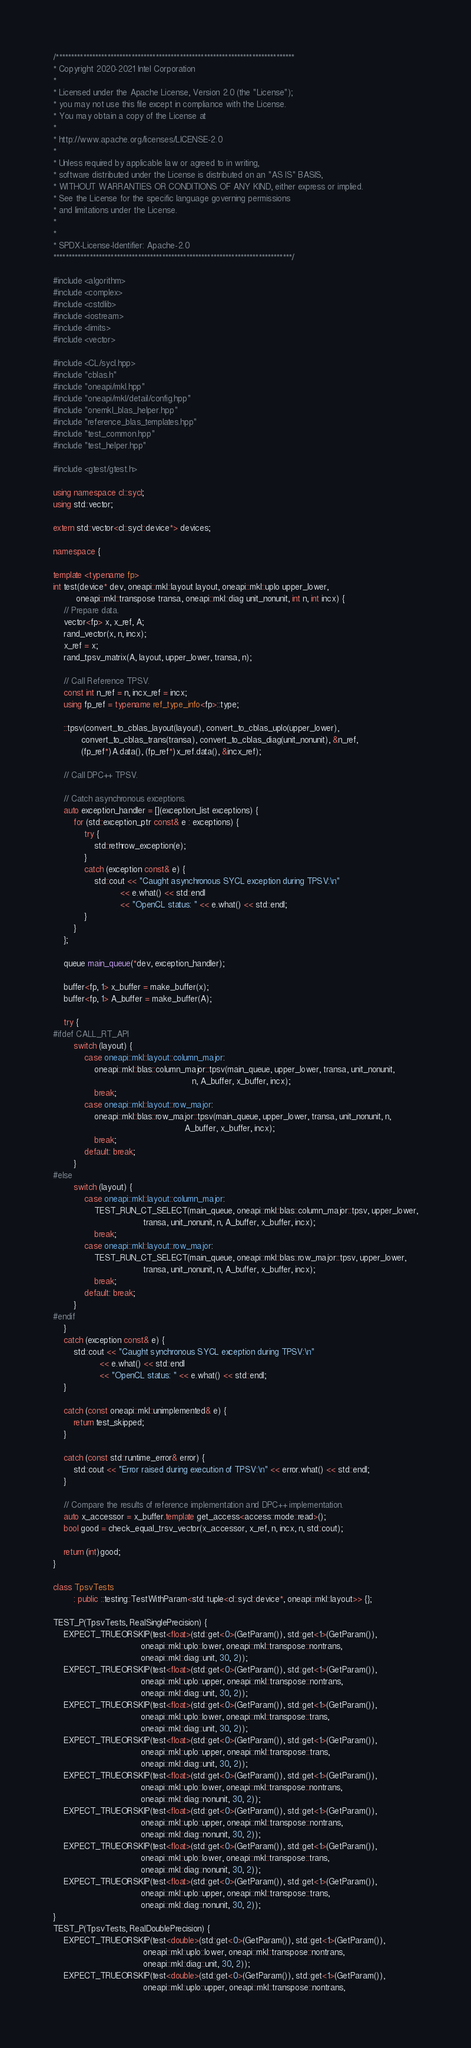<code> <loc_0><loc_0><loc_500><loc_500><_C++_>/*******************************************************************************
* Copyright 2020-2021 Intel Corporation
*
* Licensed under the Apache License, Version 2.0 (the "License");
* you may not use this file except in compliance with the License.
* You may obtain a copy of the License at
*
* http://www.apache.org/licenses/LICENSE-2.0
*
* Unless required by applicable law or agreed to in writing,
* software distributed under the License is distributed on an "AS IS" BASIS,
* WITHOUT WARRANTIES OR CONDITIONS OF ANY KIND, either express or implied.
* See the License for the specific language governing permissions
* and limitations under the License.
*
*
* SPDX-License-Identifier: Apache-2.0
*******************************************************************************/

#include <algorithm>
#include <complex>
#include <cstdlib>
#include <iostream>
#include <limits>
#include <vector>

#include <CL/sycl.hpp>
#include "cblas.h"
#include "oneapi/mkl.hpp"
#include "oneapi/mkl/detail/config.hpp"
#include "onemkl_blas_helper.hpp"
#include "reference_blas_templates.hpp"
#include "test_common.hpp"
#include "test_helper.hpp"

#include <gtest/gtest.h>

using namespace cl::sycl;
using std::vector;

extern std::vector<cl::sycl::device*> devices;

namespace {

template <typename fp>
int test(device* dev, oneapi::mkl::layout layout, oneapi::mkl::uplo upper_lower,
         oneapi::mkl::transpose transa, oneapi::mkl::diag unit_nonunit, int n, int incx) {
    // Prepare data.
    vector<fp> x, x_ref, A;
    rand_vector(x, n, incx);
    x_ref = x;
    rand_tpsv_matrix(A, layout, upper_lower, transa, n);

    // Call Reference TPSV.
    const int n_ref = n, incx_ref = incx;
    using fp_ref = typename ref_type_info<fp>::type;

    ::tpsv(convert_to_cblas_layout(layout), convert_to_cblas_uplo(upper_lower),
           convert_to_cblas_trans(transa), convert_to_cblas_diag(unit_nonunit), &n_ref,
           (fp_ref*)A.data(), (fp_ref*)x_ref.data(), &incx_ref);

    // Call DPC++ TPSV.

    // Catch asynchronous exceptions.
    auto exception_handler = [](exception_list exceptions) {
        for (std::exception_ptr const& e : exceptions) {
            try {
                std::rethrow_exception(e);
            }
            catch (exception const& e) {
                std::cout << "Caught asynchronous SYCL exception during TPSV:\n"
                          << e.what() << std::endl
                          << "OpenCL status: " << e.what() << std::endl;
            }
        }
    };

    queue main_queue(*dev, exception_handler);

    buffer<fp, 1> x_buffer = make_buffer(x);
    buffer<fp, 1> A_buffer = make_buffer(A);

    try {
#ifdef CALL_RT_API
        switch (layout) {
            case oneapi::mkl::layout::column_major:
                oneapi::mkl::blas::column_major::tpsv(main_queue, upper_lower, transa, unit_nonunit,
                                                      n, A_buffer, x_buffer, incx);
                break;
            case oneapi::mkl::layout::row_major:
                oneapi::mkl::blas::row_major::tpsv(main_queue, upper_lower, transa, unit_nonunit, n,
                                                   A_buffer, x_buffer, incx);
                break;
            default: break;
        }
#else
        switch (layout) {
            case oneapi::mkl::layout::column_major:
                TEST_RUN_CT_SELECT(main_queue, oneapi::mkl::blas::column_major::tpsv, upper_lower,
                                   transa, unit_nonunit, n, A_buffer, x_buffer, incx);
                break;
            case oneapi::mkl::layout::row_major:
                TEST_RUN_CT_SELECT(main_queue, oneapi::mkl::blas::row_major::tpsv, upper_lower,
                                   transa, unit_nonunit, n, A_buffer, x_buffer, incx);
                break;
            default: break;
        }
#endif
    }
    catch (exception const& e) {
        std::cout << "Caught synchronous SYCL exception during TPSV:\n"
                  << e.what() << std::endl
                  << "OpenCL status: " << e.what() << std::endl;
    }

    catch (const oneapi::mkl::unimplemented& e) {
        return test_skipped;
    }

    catch (const std::runtime_error& error) {
        std::cout << "Error raised during execution of TPSV:\n" << error.what() << std::endl;
    }

    // Compare the results of reference implementation and DPC++ implementation.
    auto x_accessor = x_buffer.template get_access<access::mode::read>();
    bool good = check_equal_trsv_vector(x_accessor, x_ref, n, incx, n, std::cout);

    return (int)good;
}

class TpsvTests
        : public ::testing::TestWithParam<std::tuple<cl::sycl::device*, oneapi::mkl::layout>> {};

TEST_P(TpsvTests, RealSinglePrecision) {
    EXPECT_TRUEORSKIP(test<float>(std::get<0>(GetParam()), std::get<1>(GetParam()),
                                  oneapi::mkl::uplo::lower, oneapi::mkl::transpose::nontrans,
                                  oneapi::mkl::diag::unit, 30, 2));
    EXPECT_TRUEORSKIP(test<float>(std::get<0>(GetParam()), std::get<1>(GetParam()),
                                  oneapi::mkl::uplo::upper, oneapi::mkl::transpose::nontrans,
                                  oneapi::mkl::diag::unit, 30, 2));
    EXPECT_TRUEORSKIP(test<float>(std::get<0>(GetParam()), std::get<1>(GetParam()),
                                  oneapi::mkl::uplo::lower, oneapi::mkl::transpose::trans,
                                  oneapi::mkl::diag::unit, 30, 2));
    EXPECT_TRUEORSKIP(test<float>(std::get<0>(GetParam()), std::get<1>(GetParam()),
                                  oneapi::mkl::uplo::upper, oneapi::mkl::transpose::trans,
                                  oneapi::mkl::diag::unit, 30, 2));
    EXPECT_TRUEORSKIP(test<float>(std::get<0>(GetParam()), std::get<1>(GetParam()),
                                  oneapi::mkl::uplo::lower, oneapi::mkl::transpose::nontrans,
                                  oneapi::mkl::diag::nonunit, 30, 2));
    EXPECT_TRUEORSKIP(test<float>(std::get<0>(GetParam()), std::get<1>(GetParam()),
                                  oneapi::mkl::uplo::upper, oneapi::mkl::transpose::nontrans,
                                  oneapi::mkl::diag::nonunit, 30, 2));
    EXPECT_TRUEORSKIP(test<float>(std::get<0>(GetParam()), std::get<1>(GetParam()),
                                  oneapi::mkl::uplo::lower, oneapi::mkl::transpose::trans,
                                  oneapi::mkl::diag::nonunit, 30, 2));
    EXPECT_TRUEORSKIP(test<float>(std::get<0>(GetParam()), std::get<1>(GetParam()),
                                  oneapi::mkl::uplo::upper, oneapi::mkl::transpose::trans,
                                  oneapi::mkl::diag::nonunit, 30, 2));
}
TEST_P(TpsvTests, RealDoublePrecision) {
    EXPECT_TRUEORSKIP(test<double>(std::get<0>(GetParam()), std::get<1>(GetParam()),
                                   oneapi::mkl::uplo::lower, oneapi::mkl::transpose::nontrans,
                                   oneapi::mkl::diag::unit, 30, 2));
    EXPECT_TRUEORSKIP(test<double>(std::get<0>(GetParam()), std::get<1>(GetParam()),
                                   oneapi::mkl::uplo::upper, oneapi::mkl::transpose::nontrans,</code> 